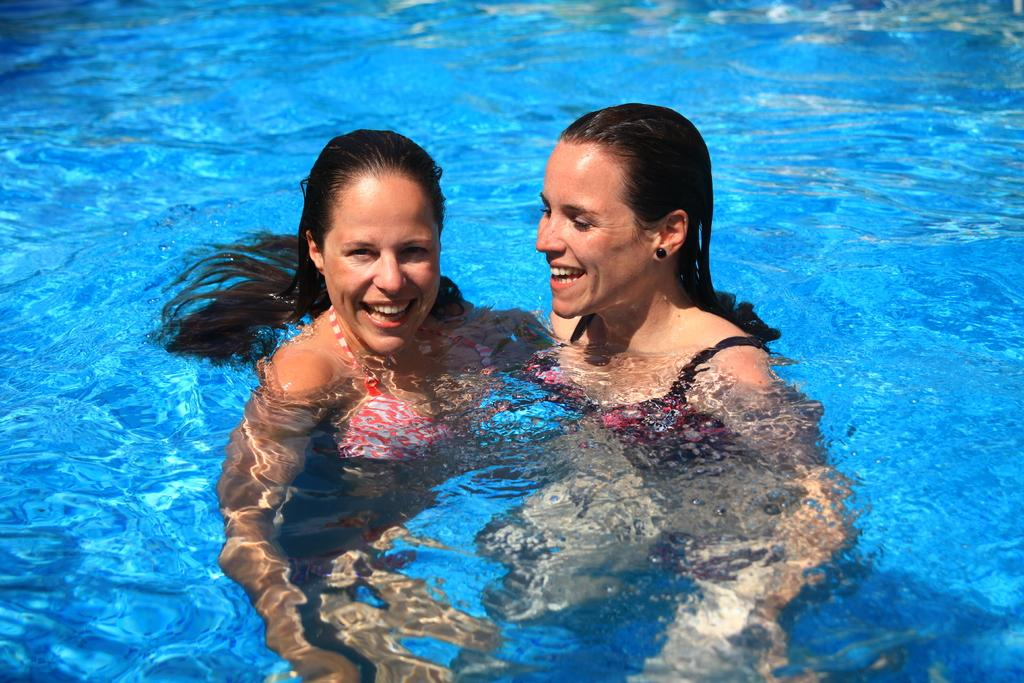What is the main subject of the image? The image depicts a swimming pool. What are the women in the water doing? The women are swimming and smiling. Can you describe the facial expressions of the women? The women are smiling in the image. Is there any interaction between the women and the person taking the picture? One of the women is looking at the picture, which suggests some interaction. What type of instrument is the sister playing in the image? There is no sister or instrument present in the image. 